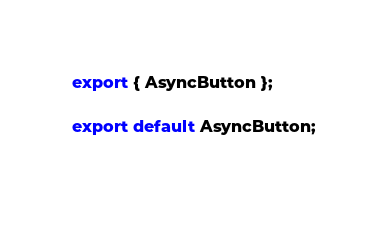Convert code to text. <code><loc_0><loc_0><loc_500><loc_500><_JavaScript_>
export { AsyncButton };

export default AsyncButton;
 </code> 